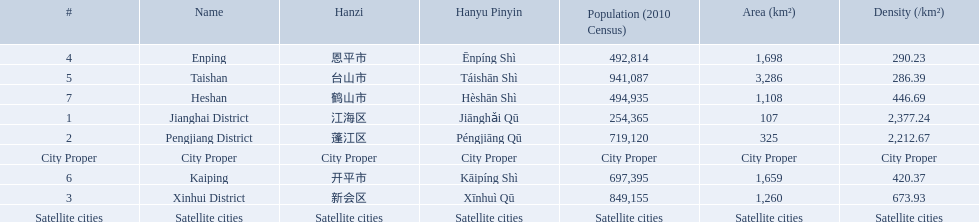What city propers are listed? Jianghai District, Pengjiang District, Xinhui District. Which hast he smallest area in km2? Jianghai District. 